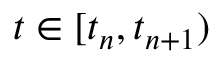<formula> <loc_0><loc_0><loc_500><loc_500>t \in [ t _ { n } , t _ { n + 1 } )</formula> 